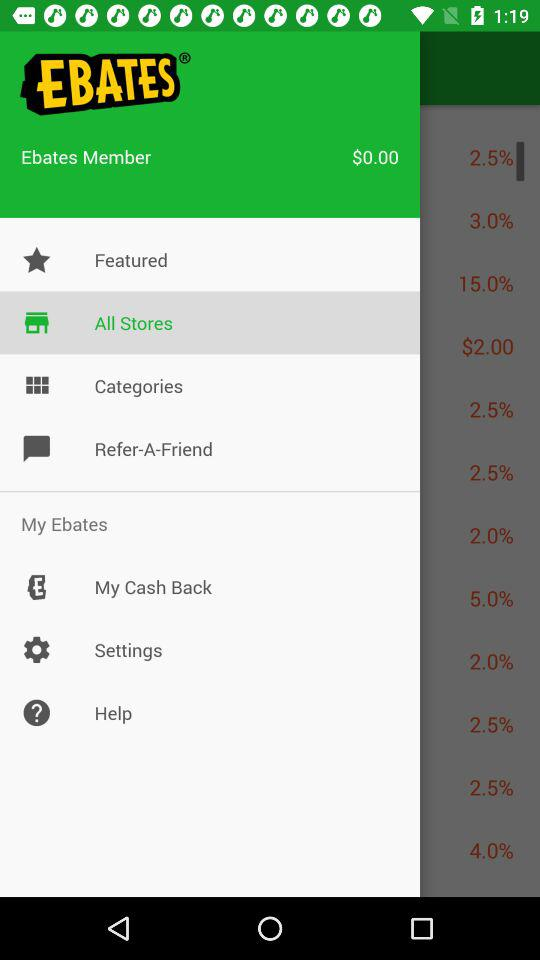How many points are in the eBates account?
When the provided information is insufficient, respond with <no answer>. <no answer> 